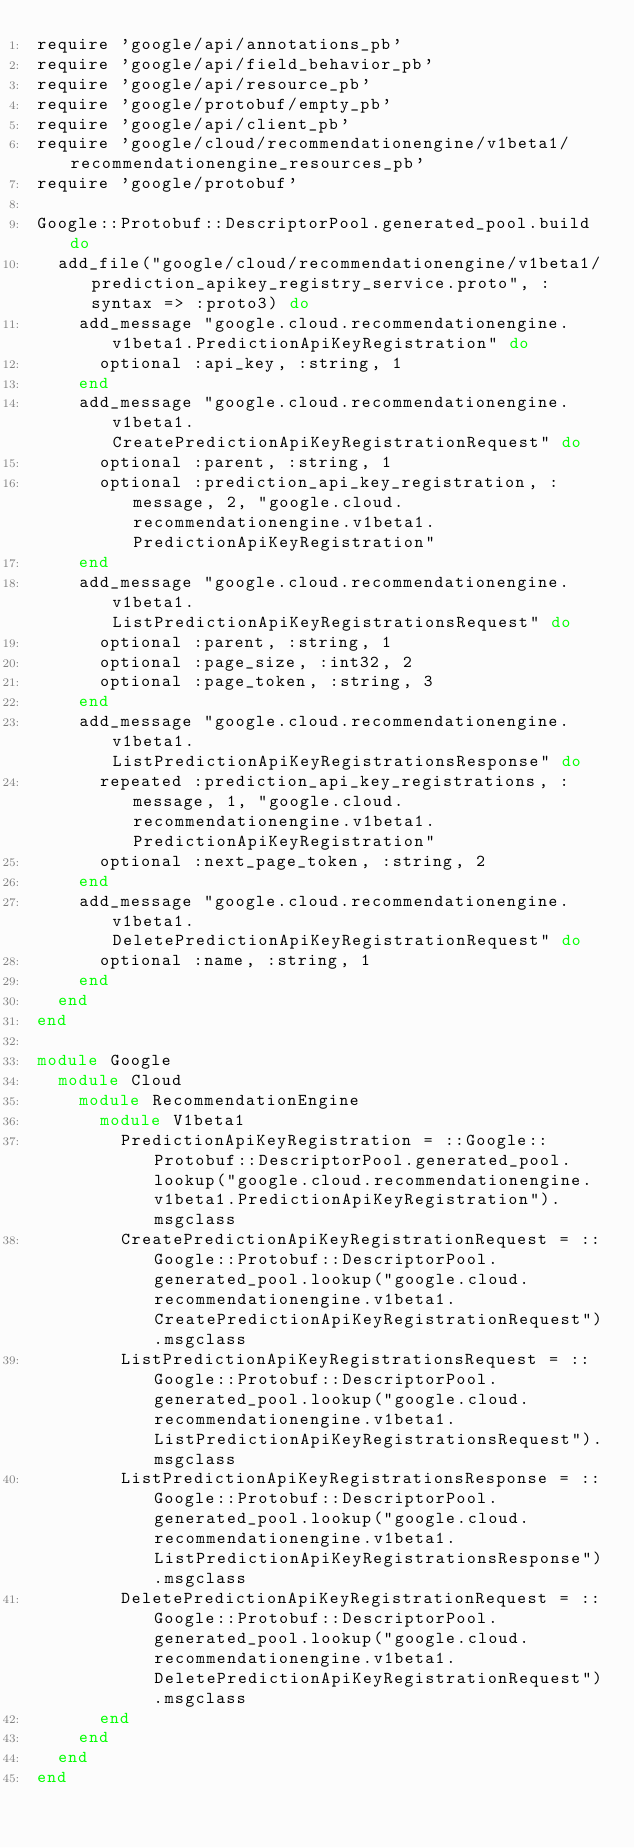Convert code to text. <code><loc_0><loc_0><loc_500><loc_500><_Ruby_>require 'google/api/annotations_pb'
require 'google/api/field_behavior_pb'
require 'google/api/resource_pb'
require 'google/protobuf/empty_pb'
require 'google/api/client_pb'
require 'google/cloud/recommendationengine/v1beta1/recommendationengine_resources_pb'
require 'google/protobuf'

Google::Protobuf::DescriptorPool.generated_pool.build do
  add_file("google/cloud/recommendationengine/v1beta1/prediction_apikey_registry_service.proto", :syntax => :proto3) do
    add_message "google.cloud.recommendationengine.v1beta1.PredictionApiKeyRegistration" do
      optional :api_key, :string, 1
    end
    add_message "google.cloud.recommendationengine.v1beta1.CreatePredictionApiKeyRegistrationRequest" do
      optional :parent, :string, 1
      optional :prediction_api_key_registration, :message, 2, "google.cloud.recommendationengine.v1beta1.PredictionApiKeyRegistration"
    end
    add_message "google.cloud.recommendationengine.v1beta1.ListPredictionApiKeyRegistrationsRequest" do
      optional :parent, :string, 1
      optional :page_size, :int32, 2
      optional :page_token, :string, 3
    end
    add_message "google.cloud.recommendationengine.v1beta1.ListPredictionApiKeyRegistrationsResponse" do
      repeated :prediction_api_key_registrations, :message, 1, "google.cloud.recommendationengine.v1beta1.PredictionApiKeyRegistration"
      optional :next_page_token, :string, 2
    end
    add_message "google.cloud.recommendationengine.v1beta1.DeletePredictionApiKeyRegistrationRequest" do
      optional :name, :string, 1
    end
  end
end

module Google
  module Cloud
    module RecommendationEngine
      module V1beta1
        PredictionApiKeyRegistration = ::Google::Protobuf::DescriptorPool.generated_pool.lookup("google.cloud.recommendationengine.v1beta1.PredictionApiKeyRegistration").msgclass
        CreatePredictionApiKeyRegistrationRequest = ::Google::Protobuf::DescriptorPool.generated_pool.lookup("google.cloud.recommendationengine.v1beta1.CreatePredictionApiKeyRegistrationRequest").msgclass
        ListPredictionApiKeyRegistrationsRequest = ::Google::Protobuf::DescriptorPool.generated_pool.lookup("google.cloud.recommendationengine.v1beta1.ListPredictionApiKeyRegistrationsRequest").msgclass
        ListPredictionApiKeyRegistrationsResponse = ::Google::Protobuf::DescriptorPool.generated_pool.lookup("google.cloud.recommendationengine.v1beta1.ListPredictionApiKeyRegistrationsResponse").msgclass
        DeletePredictionApiKeyRegistrationRequest = ::Google::Protobuf::DescriptorPool.generated_pool.lookup("google.cloud.recommendationengine.v1beta1.DeletePredictionApiKeyRegistrationRequest").msgclass
      end
    end
  end
end
</code> 